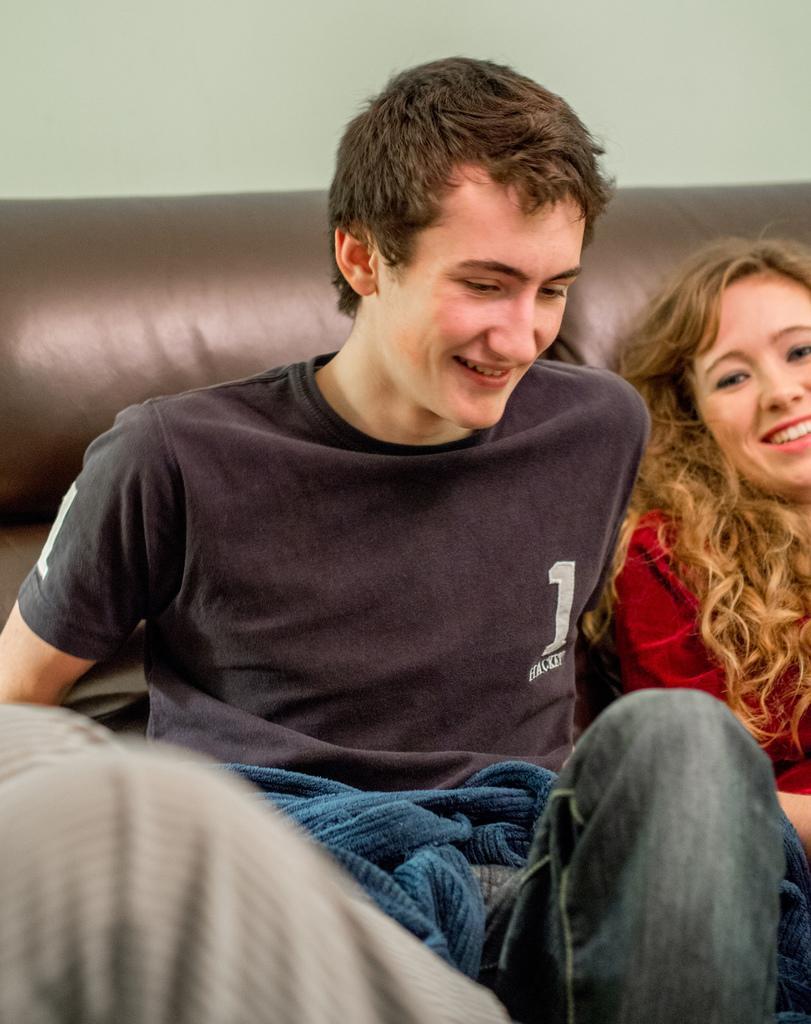Could you give a brief overview of what you see in this image? In this picture we can see there are two people sitting on a couch and in front of the man there are clothes. Behind the people there is a wall. 